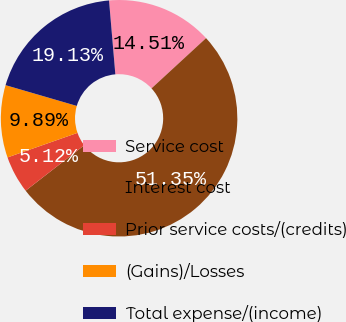Convert chart to OTSL. <chart><loc_0><loc_0><loc_500><loc_500><pie_chart><fcel>Service cost<fcel>Interest cost<fcel>Prior service costs/(credits)<fcel>(Gains)/Losses<fcel>Total expense/(income)<nl><fcel>14.51%<fcel>51.36%<fcel>5.12%<fcel>9.89%<fcel>19.13%<nl></chart> 